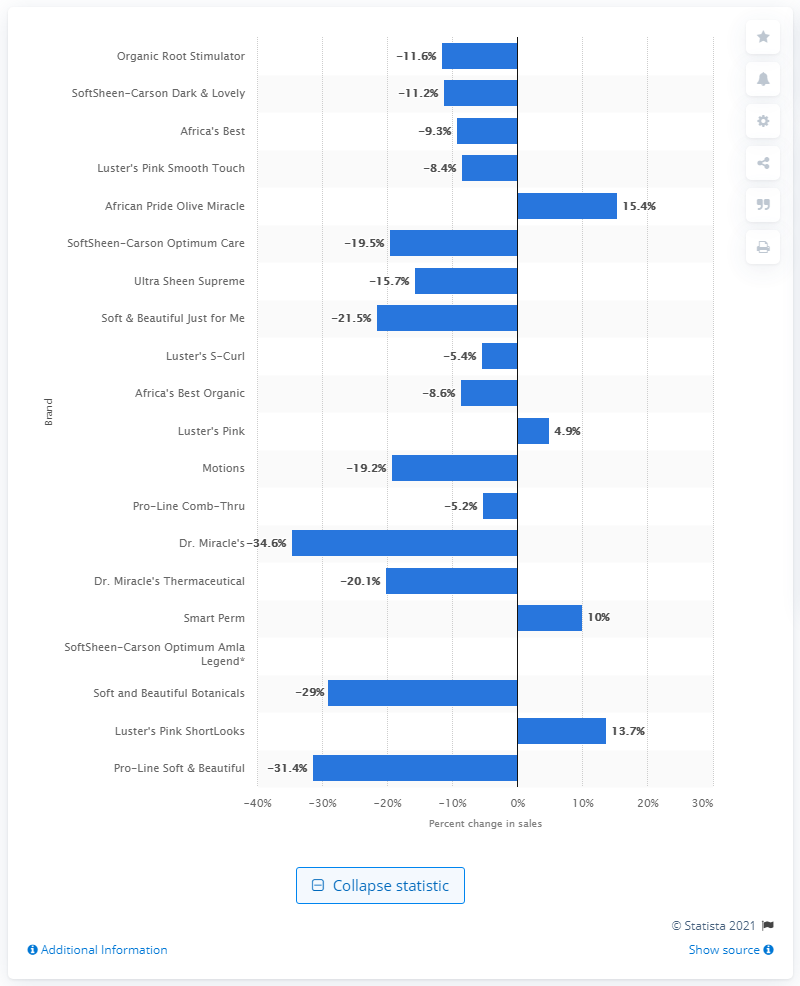Outline some significant characteristics in this image. The sales increase for African Pride Olive Miracle was 15.4%. 